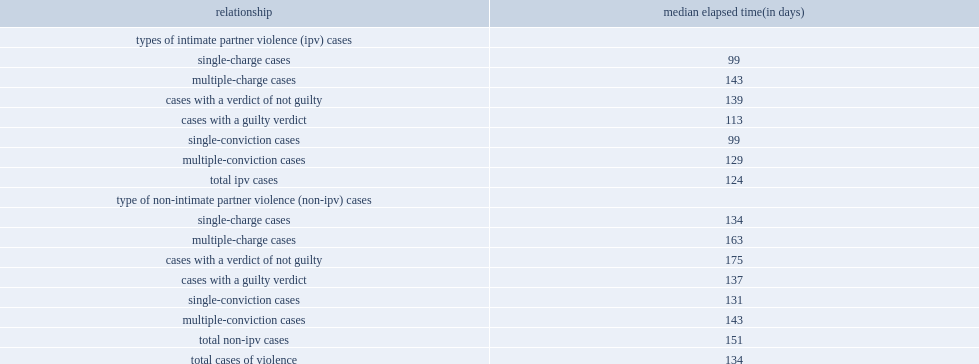What is the median processing time for all completed cases covered in this analysis, between 2005-2006 and 2010-2011? 134.0. Which type of the cases has a shorter median elapsed time? ipv cases or non-ipv cases? Total ipv cases. From the first appearance to the completion of ipv cases, what is the median processing time for cases with a single charge and for cases with two or more charges, respectively? 99.0 143.0. 